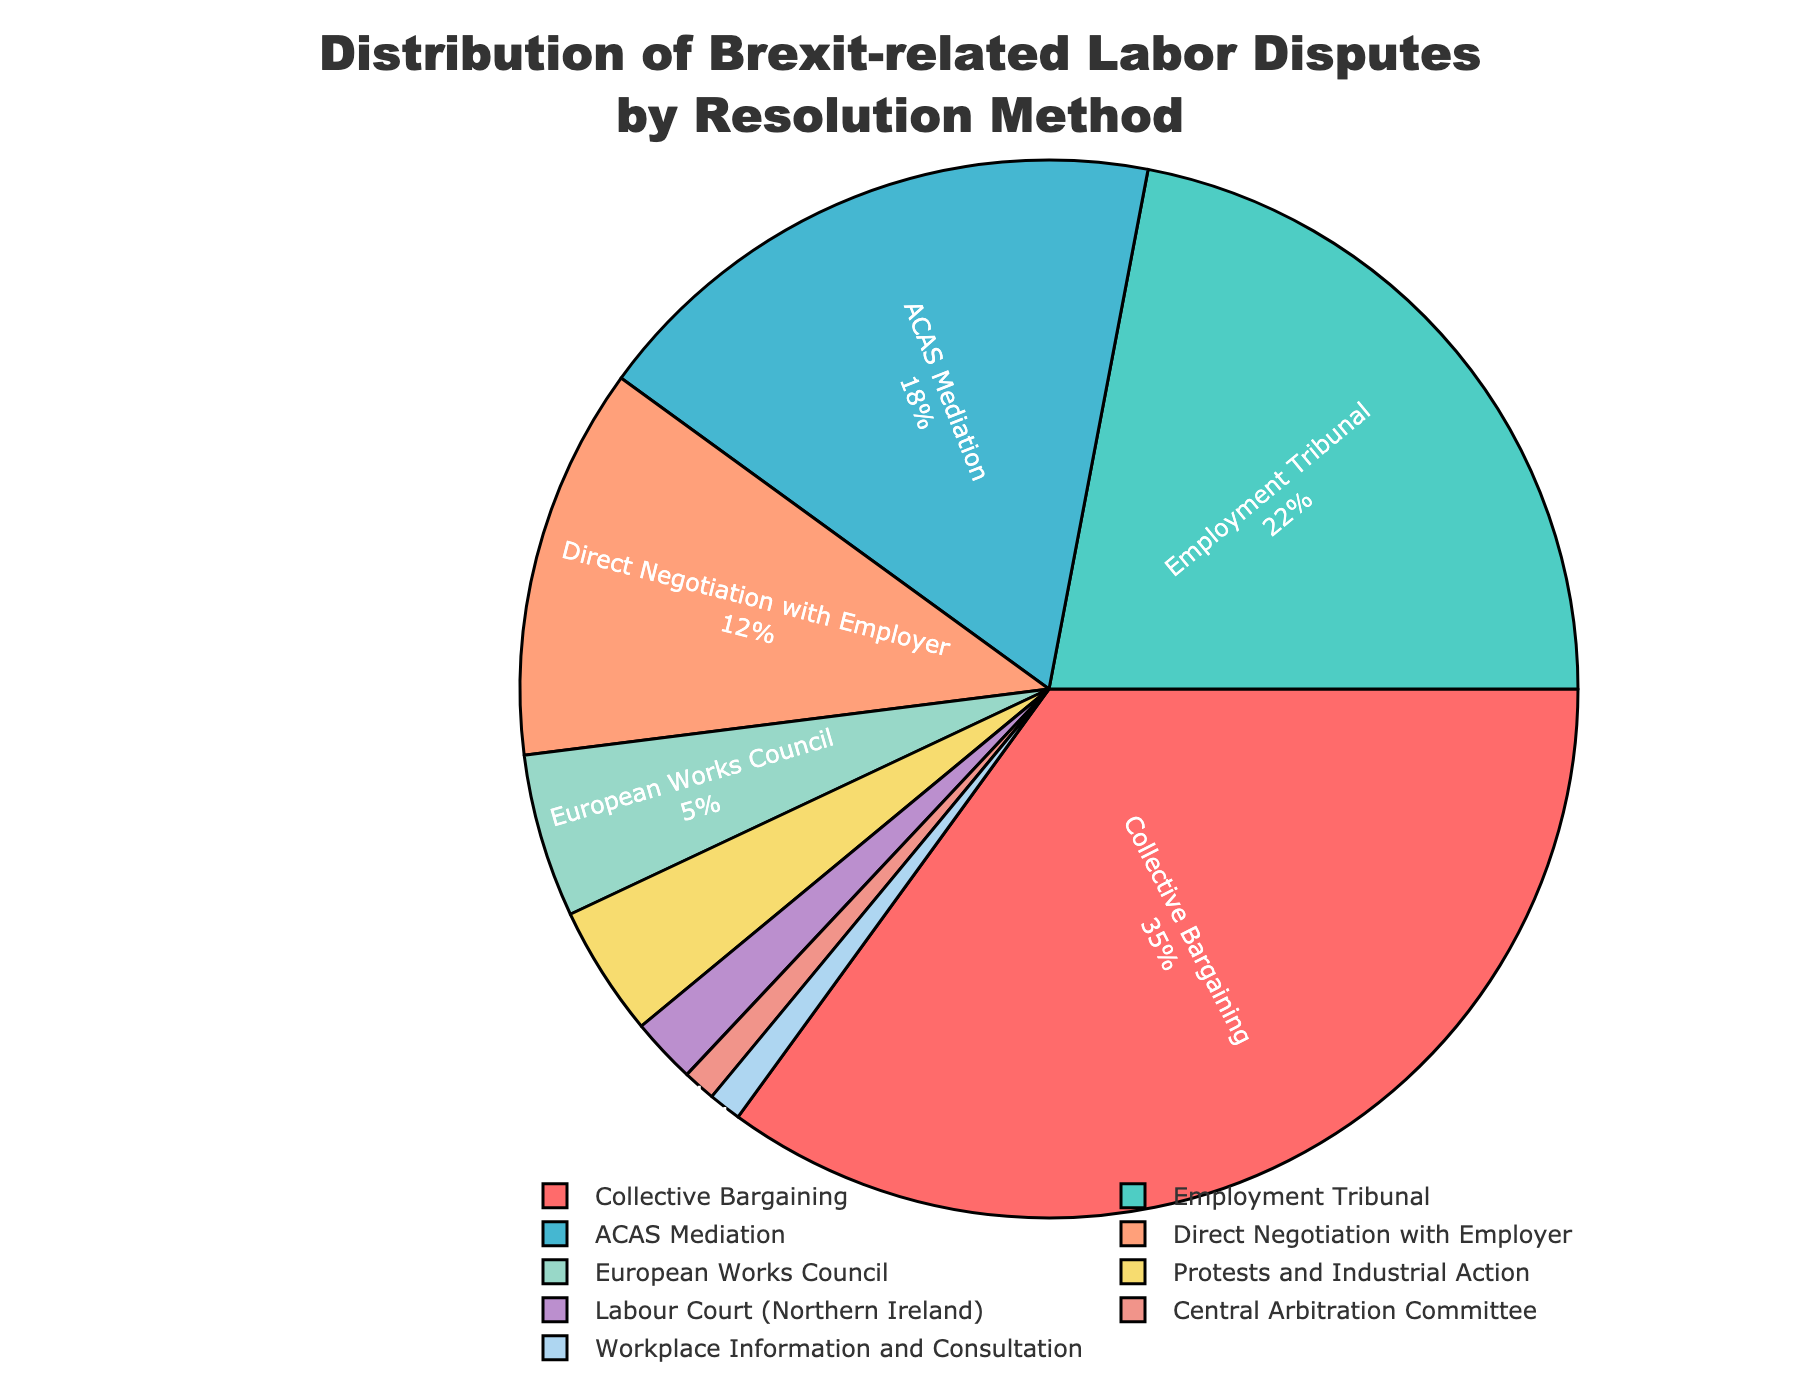Which resolution method has the highest percentage? To determine which resolution method has the highest percentage, look for the largest segment of the pie chart. This segment represents Collective Bargaining at 35%.
Answer: Collective Bargaining What combined percentage of labor disputes are resolved through ACAS Mediation and Employment Tribunal? Add the percentages of ACAS Mediation (18%) and Employment Tribunal (22%). 18% + 22% = 40%.
Answer: 40% Which resolution method has a percentage that is more than three times that of Direct Negotiation with Employer? Direct Negotiation with Employer has 12%. The resolution method with more than three times this percentage is Collective Bargaining at 35% (35% > 3 * 12%).
Answer: Collective Bargaining How many methods resolve 5% or fewer of the labor disputes? Data points labeled with 5% or fewer need to be counted: European Works Council (5%), Protests and Industrial Action (4%), Labour Court (Northern Ireland) (2%), Central Arbitration Committee (1%), and Workplace Information and Consultation (1%). There are 5 methods.
Answer: 5 What is the smallest percentage for any given resolution method, and which method does it represent? Look for the smallest percentage section in the pie chart, which is 1%, representing both Central Arbitration Committee and Workplace Information and Consultation.
Answer: 1%, Central Arbitration Committee and Workplace Information and Consultation Is the percentage of disputes resolved by Employment Tribunal greater than the combined percentage of those resolved by Labour Court and Central Arbitration Committee? Compare the percentage of Employment Tribunal (22%) with the sum of Labour Court (2%) and Central Arbitration Committee (1%). 22% > 2% + 1% = 3%.
Answer: Yes Which resolution methods collectively account for less than 10% of the disputes? Sum the percentages of resolution methods less than 10%. This includes European Works Council (5%), Protests and Industrial Action (4%), Labour Court (Northern Ireland) (2%), Central Arbitration Committee (1%), and Workplace Information and Consultation (1%). Total: 5% + 4% + 2% + 1% + 1% = 13%, which collectively count but only the ones less than 10% are 5 methods.
Answer: European Works Council, Protests and Industrial Action, Labour Court (Northern Ireland), Central Arbitration Committee, Workplace Information and Consultation Between Direct Negotiation with Employer and European Works Council, which method resolves a greater percentage of labor disputes? Compare the percentages: Direct Negotiation with Employer is at 12%, while European Works Council is at 5%. 12% > 5%.
Answer: Direct Negotiation with Employer What is the difference in percentage between the highest and the lowest resolution methods? Subtract the smallest percentage (1%) from the largest percentage (35%). 35% - 1% = 34%.
Answer: 34% 